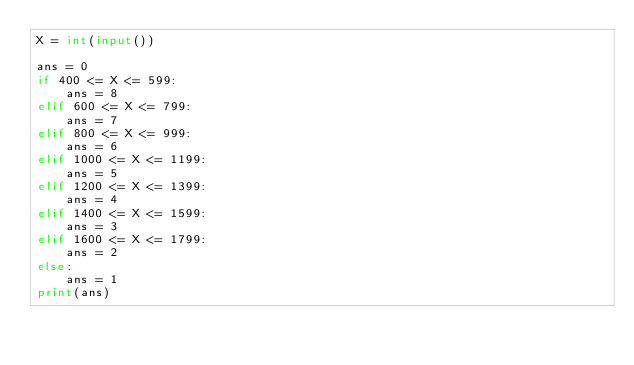Convert code to text. <code><loc_0><loc_0><loc_500><loc_500><_Python_>X = int(input())

ans = 0
if 400 <= X <= 599:
    ans = 8
elif 600 <= X <= 799:
    ans = 7
elif 800 <= X <= 999:
    ans = 6
elif 1000 <= X <= 1199:
    ans = 5
elif 1200 <= X <= 1399:
    ans = 4
elif 1400 <= X <= 1599:
    ans = 3
elif 1600 <= X <= 1799:
    ans = 2
else:
    ans = 1
print(ans)</code> 